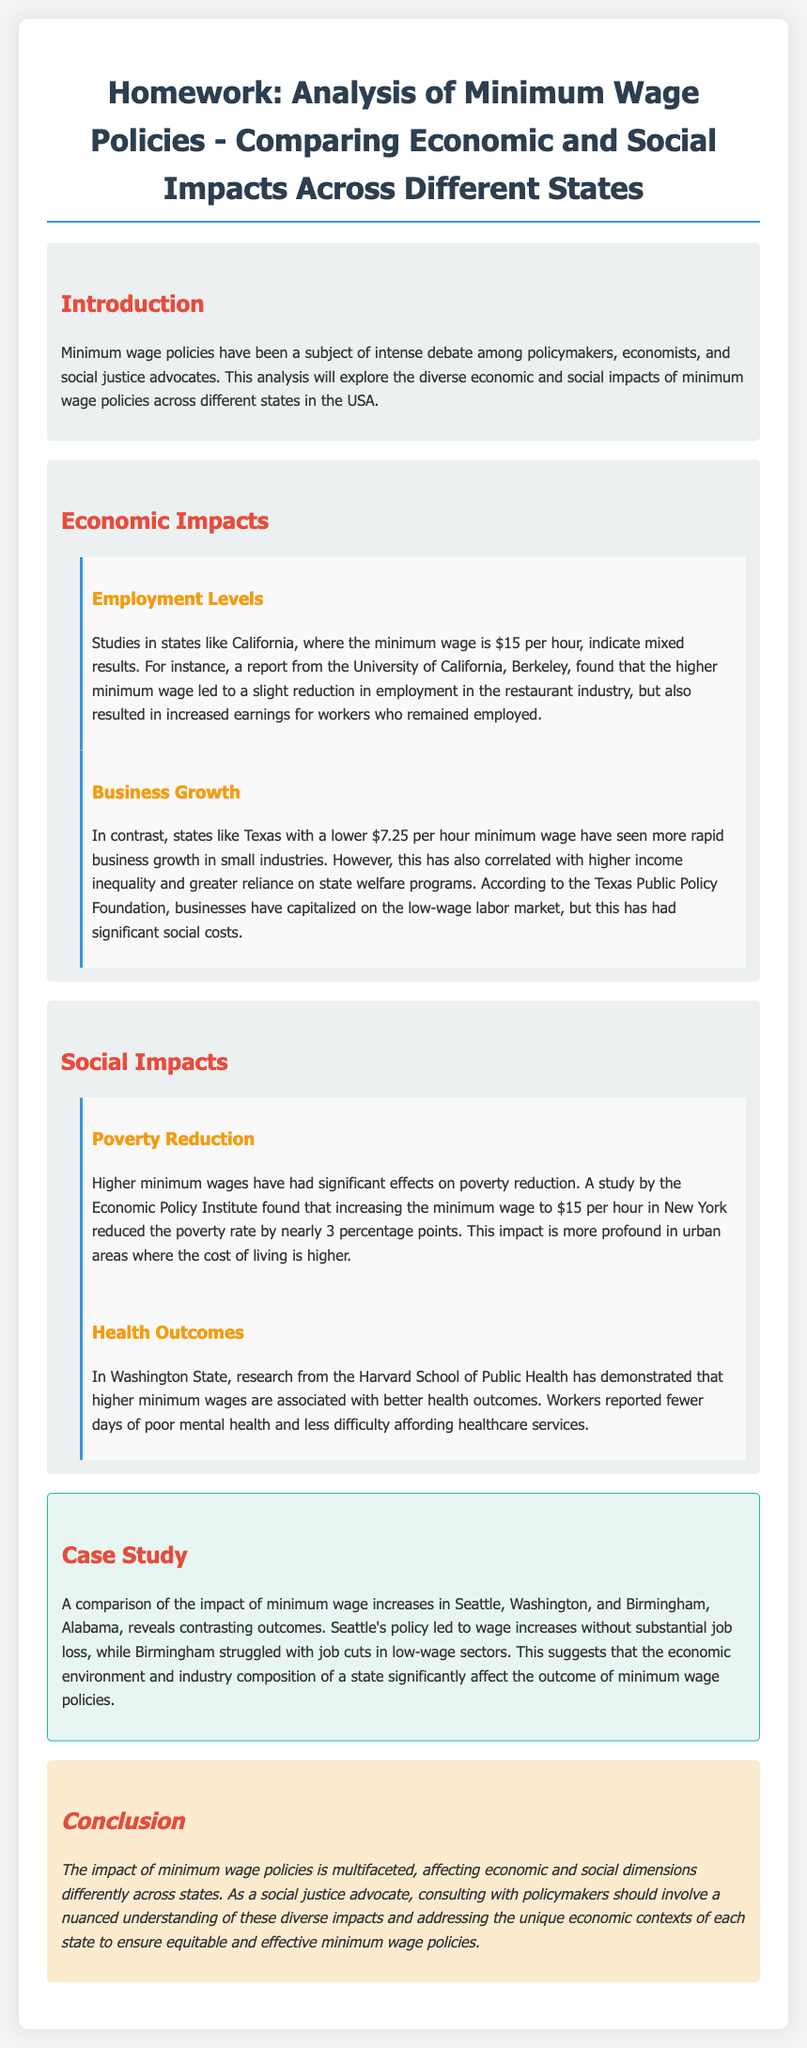what is the minimum wage in California? The document states that the minimum wage in California is $15 per hour.
Answer: $15 per hour what was the poverty rate reduction in New York after increasing the minimum wage? According to the Economic Policy Institute, the poverty rate reduced by nearly 3 percentage points in New York after the wage increase.
Answer: nearly 3 percentage points which state showed better health outcomes related to higher minimum wages? The document mentions that Washington State demonstrated better health outcomes associated with higher minimum wages.
Answer: Washington State what was a significant social cost of the low minimum wage in Texas? The document indicates that higher income inequality was a significant social cost associated with Texas's lower minimum wage.
Answer: higher income inequality how did Seattle's minimum wage policy impact job loss? The document notes that Seattle's policy led to wage increases without substantial job loss.
Answer: without substantial job loss what type of analysis does the document present? The document presents an analysis comparing economic and social impacts of minimum wage policies across different states.
Answer: analysis comparing economic and social impacts which two cities were compared in the case study? The comparison is made between Seattle, Washington, and Birmingham, Alabama in the case study.
Answer: Seattle and Birmingham what is the primary focus of the homework assignment? The primary focus of the homework assignment is on analyzing minimum wage policies and their impacts.
Answer: analyzing minimum wage policies and their impacts 